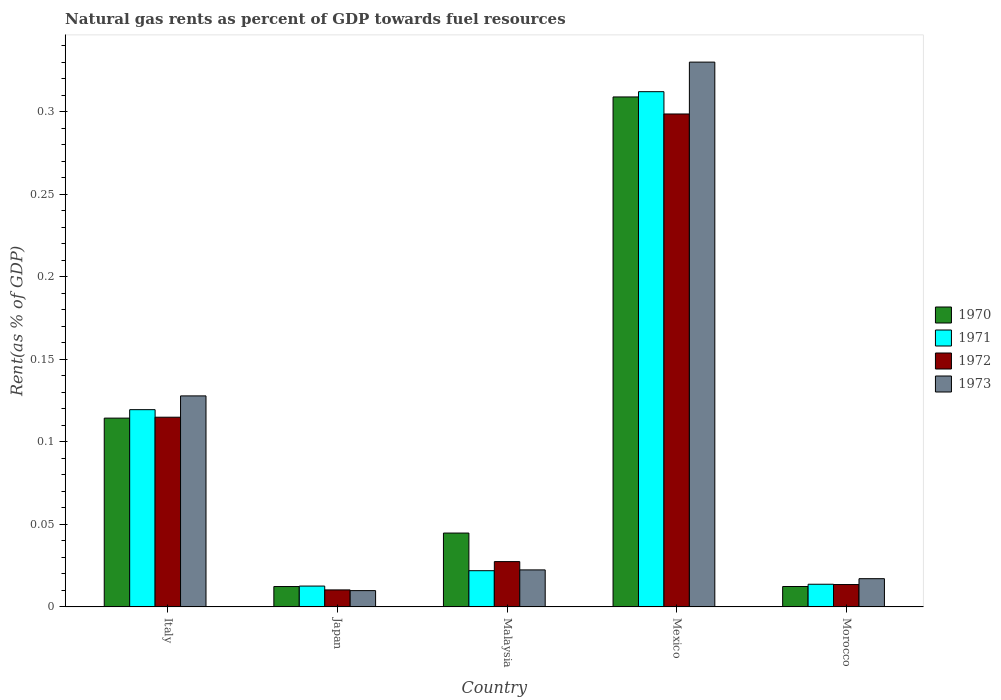How many different coloured bars are there?
Give a very brief answer. 4. How many groups of bars are there?
Give a very brief answer. 5. How many bars are there on the 1st tick from the left?
Offer a terse response. 4. How many bars are there on the 3rd tick from the right?
Give a very brief answer. 4. What is the matural gas rent in 1973 in Malaysia?
Keep it short and to the point. 0.02. Across all countries, what is the maximum matural gas rent in 1972?
Offer a very short reply. 0.3. Across all countries, what is the minimum matural gas rent in 1973?
Keep it short and to the point. 0.01. What is the total matural gas rent in 1972 in the graph?
Provide a succinct answer. 0.46. What is the difference between the matural gas rent in 1973 in Japan and that in Mexico?
Give a very brief answer. -0.32. What is the difference between the matural gas rent in 1970 in Morocco and the matural gas rent in 1971 in Italy?
Make the answer very short. -0.11. What is the average matural gas rent in 1970 per country?
Your answer should be compact. 0.1. What is the difference between the matural gas rent of/in 1973 and matural gas rent of/in 1971 in Morocco?
Offer a very short reply. 0. In how many countries, is the matural gas rent in 1970 greater than 0.1 %?
Give a very brief answer. 2. What is the ratio of the matural gas rent in 1972 in Japan to that in Malaysia?
Provide a succinct answer. 0.38. Is the matural gas rent in 1970 in Malaysia less than that in Mexico?
Offer a terse response. Yes. What is the difference between the highest and the second highest matural gas rent in 1972?
Offer a terse response. 0.18. What is the difference between the highest and the lowest matural gas rent in 1972?
Your answer should be compact. 0.29. Is it the case that in every country, the sum of the matural gas rent in 1971 and matural gas rent in 1973 is greater than the sum of matural gas rent in 1970 and matural gas rent in 1972?
Ensure brevity in your answer.  No. What does the 3rd bar from the right in Mexico represents?
Provide a succinct answer. 1971. Is it the case that in every country, the sum of the matural gas rent in 1970 and matural gas rent in 1973 is greater than the matural gas rent in 1971?
Make the answer very short. Yes. How many countries are there in the graph?
Offer a very short reply. 5. Are the values on the major ticks of Y-axis written in scientific E-notation?
Ensure brevity in your answer.  No. Does the graph contain grids?
Ensure brevity in your answer.  No. How many legend labels are there?
Make the answer very short. 4. How are the legend labels stacked?
Your answer should be very brief. Vertical. What is the title of the graph?
Your response must be concise. Natural gas rents as percent of GDP towards fuel resources. What is the label or title of the X-axis?
Provide a short and direct response. Country. What is the label or title of the Y-axis?
Keep it short and to the point. Rent(as % of GDP). What is the Rent(as % of GDP) of 1970 in Italy?
Offer a terse response. 0.11. What is the Rent(as % of GDP) of 1971 in Italy?
Provide a short and direct response. 0.12. What is the Rent(as % of GDP) in 1972 in Italy?
Offer a very short reply. 0.11. What is the Rent(as % of GDP) of 1973 in Italy?
Your answer should be compact. 0.13. What is the Rent(as % of GDP) of 1970 in Japan?
Your response must be concise. 0.01. What is the Rent(as % of GDP) of 1971 in Japan?
Your answer should be very brief. 0.01. What is the Rent(as % of GDP) of 1972 in Japan?
Provide a succinct answer. 0.01. What is the Rent(as % of GDP) in 1973 in Japan?
Provide a short and direct response. 0.01. What is the Rent(as % of GDP) in 1970 in Malaysia?
Provide a short and direct response. 0.04. What is the Rent(as % of GDP) in 1971 in Malaysia?
Provide a succinct answer. 0.02. What is the Rent(as % of GDP) in 1972 in Malaysia?
Provide a short and direct response. 0.03. What is the Rent(as % of GDP) in 1973 in Malaysia?
Provide a short and direct response. 0.02. What is the Rent(as % of GDP) of 1970 in Mexico?
Offer a terse response. 0.31. What is the Rent(as % of GDP) of 1971 in Mexico?
Provide a short and direct response. 0.31. What is the Rent(as % of GDP) in 1972 in Mexico?
Your response must be concise. 0.3. What is the Rent(as % of GDP) in 1973 in Mexico?
Your answer should be compact. 0.33. What is the Rent(as % of GDP) in 1970 in Morocco?
Your answer should be very brief. 0.01. What is the Rent(as % of GDP) in 1971 in Morocco?
Make the answer very short. 0.01. What is the Rent(as % of GDP) of 1972 in Morocco?
Your response must be concise. 0.01. What is the Rent(as % of GDP) of 1973 in Morocco?
Your response must be concise. 0.02. Across all countries, what is the maximum Rent(as % of GDP) of 1970?
Your response must be concise. 0.31. Across all countries, what is the maximum Rent(as % of GDP) in 1971?
Your answer should be very brief. 0.31. Across all countries, what is the maximum Rent(as % of GDP) in 1972?
Ensure brevity in your answer.  0.3. Across all countries, what is the maximum Rent(as % of GDP) of 1973?
Provide a short and direct response. 0.33. Across all countries, what is the minimum Rent(as % of GDP) of 1970?
Provide a succinct answer. 0.01. Across all countries, what is the minimum Rent(as % of GDP) of 1971?
Provide a succinct answer. 0.01. Across all countries, what is the minimum Rent(as % of GDP) of 1972?
Make the answer very short. 0.01. Across all countries, what is the minimum Rent(as % of GDP) in 1973?
Ensure brevity in your answer.  0.01. What is the total Rent(as % of GDP) in 1970 in the graph?
Offer a very short reply. 0.49. What is the total Rent(as % of GDP) in 1971 in the graph?
Provide a succinct answer. 0.48. What is the total Rent(as % of GDP) in 1972 in the graph?
Give a very brief answer. 0.46. What is the total Rent(as % of GDP) in 1973 in the graph?
Give a very brief answer. 0.51. What is the difference between the Rent(as % of GDP) of 1970 in Italy and that in Japan?
Your answer should be very brief. 0.1. What is the difference between the Rent(as % of GDP) in 1971 in Italy and that in Japan?
Make the answer very short. 0.11. What is the difference between the Rent(as % of GDP) in 1972 in Italy and that in Japan?
Provide a succinct answer. 0.1. What is the difference between the Rent(as % of GDP) of 1973 in Italy and that in Japan?
Your response must be concise. 0.12. What is the difference between the Rent(as % of GDP) of 1970 in Italy and that in Malaysia?
Your response must be concise. 0.07. What is the difference between the Rent(as % of GDP) of 1971 in Italy and that in Malaysia?
Give a very brief answer. 0.1. What is the difference between the Rent(as % of GDP) of 1972 in Italy and that in Malaysia?
Offer a very short reply. 0.09. What is the difference between the Rent(as % of GDP) in 1973 in Italy and that in Malaysia?
Your answer should be compact. 0.11. What is the difference between the Rent(as % of GDP) of 1970 in Italy and that in Mexico?
Give a very brief answer. -0.19. What is the difference between the Rent(as % of GDP) in 1971 in Italy and that in Mexico?
Keep it short and to the point. -0.19. What is the difference between the Rent(as % of GDP) of 1972 in Italy and that in Mexico?
Keep it short and to the point. -0.18. What is the difference between the Rent(as % of GDP) of 1973 in Italy and that in Mexico?
Your response must be concise. -0.2. What is the difference between the Rent(as % of GDP) in 1970 in Italy and that in Morocco?
Give a very brief answer. 0.1. What is the difference between the Rent(as % of GDP) in 1971 in Italy and that in Morocco?
Offer a very short reply. 0.11. What is the difference between the Rent(as % of GDP) of 1972 in Italy and that in Morocco?
Your answer should be very brief. 0.1. What is the difference between the Rent(as % of GDP) of 1973 in Italy and that in Morocco?
Offer a terse response. 0.11. What is the difference between the Rent(as % of GDP) of 1970 in Japan and that in Malaysia?
Offer a terse response. -0.03. What is the difference between the Rent(as % of GDP) of 1971 in Japan and that in Malaysia?
Offer a terse response. -0.01. What is the difference between the Rent(as % of GDP) in 1972 in Japan and that in Malaysia?
Provide a succinct answer. -0.02. What is the difference between the Rent(as % of GDP) in 1973 in Japan and that in Malaysia?
Provide a succinct answer. -0.01. What is the difference between the Rent(as % of GDP) in 1970 in Japan and that in Mexico?
Ensure brevity in your answer.  -0.3. What is the difference between the Rent(as % of GDP) in 1971 in Japan and that in Mexico?
Ensure brevity in your answer.  -0.3. What is the difference between the Rent(as % of GDP) of 1972 in Japan and that in Mexico?
Give a very brief answer. -0.29. What is the difference between the Rent(as % of GDP) in 1973 in Japan and that in Mexico?
Your response must be concise. -0.32. What is the difference between the Rent(as % of GDP) of 1971 in Japan and that in Morocco?
Make the answer very short. -0. What is the difference between the Rent(as % of GDP) of 1972 in Japan and that in Morocco?
Offer a very short reply. -0. What is the difference between the Rent(as % of GDP) in 1973 in Japan and that in Morocco?
Keep it short and to the point. -0.01. What is the difference between the Rent(as % of GDP) of 1970 in Malaysia and that in Mexico?
Your answer should be compact. -0.26. What is the difference between the Rent(as % of GDP) of 1971 in Malaysia and that in Mexico?
Offer a very short reply. -0.29. What is the difference between the Rent(as % of GDP) in 1972 in Malaysia and that in Mexico?
Provide a short and direct response. -0.27. What is the difference between the Rent(as % of GDP) in 1973 in Malaysia and that in Mexico?
Your answer should be very brief. -0.31. What is the difference between the Rent(as % of GDP) in 1970 in Malaysia and that in Morocco?
Ensure brevity in your answer.  0.03. What is the difference between the Rent(as % of GDP) of 1971 in Malaysia and that in Morocco?
Your answer should be compact. 0.01. What is the difference between the Rent(as % of GDP) in 1972 in Malaysia and that in Morocco?
Your response must be concise. 0.01. What is the difference between the Rent(as % of GDP) of 1973 in Malaysia and that in Morocco?
Ensure brevity in your answer.  0.01. What is the difference between the Rent(as % of GDP) of 1970 in Mexico and that in Morocco?
Offer a very short reply. 0.3. What is the difference between the Rent(as % of GDP) in 1971 in Mexico and that in Morocco?
Your response must be concise. 0.3. What is the difference between the Rent(as % of GDP) of 1972 in Mexico and that in Morocco?
Your answer should be very brief. 0.28. What is the difference between the Rent(as % of GDP) in 1973 in Mexico and that in Morocco?
Offer a very short reply. 0.31. What is the difference between the Rent(as % of GDP) of 1970 in Italy and the Rent(as % of GDP) of 1971 in Japan?
Offer a very short reply. 0.1. What is the difference between the Rent(as % of GDP) of 1970 in Italy and the Rent(as % of GDP) of 1972 in Japan?
Provide a short and direct response. 0.1. What is the difference between the Rent(as % of GDP) of 1970 in Italy and the Rent(as % of GDP) of 1973 in Japan?
Your response must be concise. 0.1. What is the difference between the Rent(as % of GDP) in 1971 in Italy and the Rent(as % of GDP) in 1972 in Japan?
Keep it short and to the point. 0.11. What is the difference between the Rent(as % of GDP) of 1971 in Italy and the Rent(as % of GDP) of 1973 in Japan?
Provide a short and direct response. 0.11. What is the difference between the Rent(as % of GDP) of 1972 in Italy and the Rent(as % of GDP) of 1973 in Japan?
Keep it short and to the point. 0.1. What is the difference between the Rent(as % of GDP) in 1970 in Italy and the Rent(as % of GDP) in 1971 in Malaysia?
Offer a very short reply. 0.09. What is the difference between the Rent(as % of GDP) of 1970 in Italy and the Rent(as % of GDP) of 1972 in Malaysia?
Your response must be concise. 0.09. What is the difference between the Rent(as % of GDP) of 1970 in Italy and the Rent(as % of GDP) of 1973 in Malaysia?
Make the answer very short. 0.09. What is the difference between the Rent(as % of GDP) in 1971 in Italy and the Rent(as % of GDP) in 1972 in Malaysia?
Ensure brevity in your answer.  0.09. What is the difference between the Rent(as % of GDP) in 1971 in Italy and the Rent(as % of GDP) in 1973 in Malaysia?
Make the answer very short. 0.1. What is the difference between the Rent(as % of GDP) of 1972 in Italy and the Rent(as % of GDP) of 1973 in Malaysia?
Provide a short and direct response. 0.09. What is the difference between the Rent(as % of GDP) in 1970 in Italy and the Rent(as % of GDP) in 1971 in Mexico?
Keep it short and to the point. -0.2. What is the difference between the Rent(as % of GDP) in 1970 in Italy and the Rent(as % of GDP) in 1972 in Mexico?
Offer a very short reply. -0.18. What is the difference between the Rent(as % of GDP) in 1970 in Italy and the Rent(as % of GDP) in 1973 in Mexico?
Keep it short and to the point. -0.22. What is the difference between the Rent(as % of GDP) of 1971 in Italy and the Rent(as % of GDP) of 1972 in Mexico?
Keep it short and to the point. -0.18. What is the difference between the Rent(as % of GDP) of 1971 in Italy and the Rent(as % of GDP) of 1973 in Mexico?
Provide a short and direct response. -0.21. What is the difference between the Rent(as % of GDP) in 1972 in Italy and the Rent(as % of GDP) in 1973 in Mexico?
Ensure brevity in your answer.  -0.22. What is the difference between the Rent(as % of GDP) in 1970 in Italy and the Rent(as % of GDP) in 1971 in Morocco?
Make the answer very short. 0.1. What is the difference between the Rent(as % of GDP) in 1970 in Italy and the Rent(as % of GDP) in 1972 in Morocco?
Provide a succinct answer. 0.1. What is the difference between the Rent(as % of GDP) of 1970 in Italy and the Rent(as % of GDP) of 1973 in Morocco?
Make the answer very short. 0.1. What is the difference between the Rent(as % of GDP) of 1971 in Italy and the Rent(as % of GDP) of 1972 in Morocco?
Provide a short and direct response. 0.11. What is the difference between the Rent(as % of GDP) in 1971 in Italy and the Rent(as % of GDP) in 1973 in Morocco?
Offer a terse response. 0.1. What is the difference between the Rent(as % of GDP) in 1972 in Italy and the Rent(as % of GDP) in 1973 in Morocco?
Your answer should be compact. 0.1. What is the difference between the Rent(as % of GDP) in 1970 in Japan and the Rent(as % of GDP) in 1971 in Malaysia?
Provide a short and direct response. -0.01. What is the difference between the Rent(as % of GDP) of 1970 in Japan and the Rent(as % of GDP) of 1972 in Malaysia?
Give a very brief answer. -0.02. What is the difference between the Rent(as % of GDP) in 1970 in Japan and the Rent(as % of GDP) in 1973 in Malaysia?
Give a very brief answer. -0.01. What is the difference between the Rent(as % of GDP) in 1971 in Japan and the Rent(as % of GDP) in 1972 in Malaysia?
Give a very brief answer. -0.01. What is the difference between the Rent(as % of GDP) in 1971 in Japan and the Rent(as % of GDP) in 1973 in Malaysia?
Ensure brevity in your answer.  -0.01. What is the difference between the Rent(as % of GDP) of 1972 in Japan and the Rent(as % of GDP) of 1973 in Malaysia?
Keep it short and to the point. -0.01. What is the difference between the Rent(as % of GDP) of 1970 in Japan and the Rent(as % of GDP) of 1971 in Mexico?
Provide a succinct answer. -0.3. What is the difference between the Rent(as % of GDP) of 1970 in Japan and the Rent(as % of GDP) of 1972 in Mexico?
Your answer should be very brief. -0.29. What is the difference between the Rent(as % of GDP) in 1970 in Japan and the Rent(as % of GDP) in 1973 in Mexico?
Keep it short and to the point. -0.32. What is the difference between the Rent(as % of GDP) of 1971 in Japan and the Rent(as % of GDP) of 1972 in Mexico?
Make the answer very short. -0.29. What is the difference between the Rent(as % of GDP) in 1971 in Japan and the Rent(as % of GDP) in 1973 in Mexico?
Offer a very short reply. -0.32. What is the difference between the Rent(as % of GDP) in 1972 in Japan and the Rent(as % of GDP) in 1973 in Mexico?
Your response must be concise. -0.32. What is the difference between the Rent(as % of GDP) of 1970 in Japan and the Rent(as % of GDP) of 1971 in Morocco?
Your answer should be very brief. -0. What is the difference between the Rent(as % of GDP) of 1970 in Japan and the Rent(as % of GDP) of 1972 in Morocco?
Provide a short and direct response. -0. What is the difference between the Rent(as % of GDP) in 1970 in Japan and the Rent(as % of GDP) in 1973 in Morocco?
Offer a terse response. -0. What is the difference between the Rent(as % of GDP) of 1971 in Japan and the Rent(as % of GDP) of 1972 in Morocco?
Your answer should be very brief. -0. What is the difference between the Rent(as % of GDP) of 1971 in Japan and the Rent(as % of GDP) of 1973 in Morocco?
Keep it short and to the point. -0. What is the difference between the Rent(as % of GDP) of 1972 in Japan and the Rent(as % of GDP) of 1973 in Morocco?
Offer a terse response. -0.01. What is the difference between the Rent(as % of GDP) of 1970 in Malaysia and the Rent(as % of GDP) of 1971 in Mexico?
Provide a succinct answer. -0.27. What is the difference between the Rent(as % of GDP) in 1970 in Malaysia and the Rent(as % of GDP) in 1972 in Mexico?
Your response must be concise. -0.25. What is the difference between the Rent(as % of GDP) of 1970 in Malaysia and the Rent(as % of GDP) of 1973 in Mexico?
Your answer should be compact. -0.29. What is the difference between the Rent(as % of GDP) in 1971 in Malaysia and the Rent(as % of GDP) in 1972 in Mexico?
Ensure brevity in your answer.  -0.28. What is the difference between the Rent(as % of GDP) in 1971 in Malaysia and the Rent(as % of GDP) in 1973 in Mexico?
Your answer should be compact. -0.31. What is the difference between the Rent(as % of GDP) of 1972 in Malaysia and the Rent(as % of GDP) of 1973 in Mexico?
Provide a short and direct response. -0.3. What is the difference between the Rent(as % of GDP) of 1970 in Malaysia and the Rent(as % of GDP) of 1971 in Morocco?
Your response must be concise. 0.03. What is the difference between the Rent(as % of GDP) in 1970 in Malaysia and the Rent(as % of GDP) in 1972 in Morocco?
Provide a short and direct response. 0.03. What is the difference between the Rent(as % of GDP) in 1970 in Malaysia and the Rent(as % of GDP) in 1973 in Morocco?
Your answer should be very brief. 0.03. What is the difference between the Rent(as % of GDP) in 1971 in Malaysia and the Rent(as % of GDP) in 1972 in Morocco?
Provide a succinct answer. 0.01. What is the difference between the Rent(as % of GDP) in 1971 in Malaysia and the Rent(as % of GDP) in 1973 in Morocco?
Give a very brief answer. 0. What is the difference between the Rent(as % of GDP) in 1972 in Malaysia and the Rent(as % of GDP) in 1973 in Morocco?
Ensure brevity in your answer.  0.01. What is the difference between the Rent(as % of GDP) in 1970 in Mexico and the Rent(as % of GDP) in 1971 in Morocco?
Offer a terse response. 0.3. What is the difference between the Rent(as % of GDP) in 1970 in Mexico and the Rent(as % of GDP) in 1972 in Morocco?
Make the answer very short. 0.3. What is the difference between the Rent(as % of GDP) in 1970 in Mexico and the Rent(as % of GDP) in 1973 in Morocco?
Provide a short and direct response. 0.29. What is the difference between the Rent(as % of GDP) in 1971 in Mexico and the Rent(as % of GDP) in 1972 in Morocco?
Offer a terse response. 0.3. What is the difference between the Rent(as % of GDP) in 1971 in Mexico and the Rent(as % of GDP) in 1973 in Morocco?
Make the answer very short. 0.29. What is the difference between the Rent(as % of GDP) in 1972 in Mexico and the Rent(as % of GDP) in 1973 in Morocco?
Your answer should be compact. 0.28. What is the average Rent(as % of GDP) in 1970 per country?
Keep it short and to the point. 0.1. What is the average Rent(as % of GDP) of 1971 per country?
Your response must be concise. 0.1. What is the average Rent(as % of GDP) in 1972 per country?
Your answer should be compact. 0.09. What is the average Rent(as % of GDP) in 1973 per country?
Keep it short and to the point. 0.1. What is the difference between the Rent(as % of GDP) in 1970 and Rent(as % of GDP) in 1971 in Italy?
Give a very brief answer. -0.01. What is the difference between the Rent(as % of GDP) of 1970 and Rent(as % of GDP) of 1972 in Italy?
Your answer should be very brief. -0. What is the difference between the Rent(as % of GDP) in 1970 and Rent(as % of GDP) in 1973 in Italy?
Give a very brief answer. -0.01. What is the difference between the Rent(as % of GDP) in 1971 and Rent(as % of GDP) in 1972 in Italy?
Provide a succinct answer. 0. What is the difference between the Rent(as % of GDP) of 1971 and Rent(as % of GDP) of 1973 in Italy?
Ensure brevity in your answer.  -0.01. What is the difference between the Rent(as % of GDP) of 1972 and Rent(as % of GDP) of 1973 in Italy?
Keep it short and to the point. -0.01. What is the difference between the Rent(as % of GDP) of 1970 and Rent(as % of GDP) of 1971 in Japan?
Provide a short and direct response. -0. What is the difference between the Rent(as % of GDP) of 1970 and Rent(as % of GDP) of 1972 in Japan?
Keep it short and to the point. 0. What is the difference between the Rent(as % of GDP) of 1970 and Rent(as % of GDP) of 1973 in Japan?
Your answer should be very brief. 0. What is the difference between the Rent(as % of GDP) in 1971 and Rent(as % of GDP) in 1972 in Japan?
Make the answer very short. 0. What is the difference between the Rent(as % of GDP) in 1971 and Rent(as % of GDP) in 1973 in Japan?
Provide a succinct answer. 0. What is the difference between the Rent(as % of GDP) of 1970 and Rent(as % of GDP) of 1971 in Malaysia?
Your answer should be compact. 0.02. What is the difference between the Rent(as % of GDP) of 1970 and Rent(as % of GDP) of 1972 in Malaysia?
Give a very brief answer. 0.02. What is the difference between the Rent(as % of GDP) in 1970 and Rent(as % of GDP) in 1973 in Malaysia?
Give a very brief answer. 0.02. What is the difference between the Rent(as % of GDP) in 1971 and Rent(as % of GDP) in 1972 in Malaysia?
Offer a terse response. -0.01. What is the difference between the Rent(as % of GDP) in 1971 and Rent(as % of GDP) in 1973 in Malaysia?
Offer a very short reply. -0. What is the difference between the Rent(as % of GDP) in 1972 and Rent(as % of GDP) in 1973 in Malaysia?
Your answer should be compact. 0.01. What is the difference between the Rent(as % of GDP) in 1970 and Rent(as % of GDP) in 1971 in Mexico?
Provide a succinct answer. -0. What is the difference between the Rent(as % of GDP) in 1970 and Rent(as % of GDP) in 1972 in Mexico?
Your answer should be very brief. 0.01. What is the difference between the Rent(as % of GDP) of 1970 and Rent(as % of GDP) of 1973 in Mexico?
Offer a very short reply. -0.02. What is the difference between the Rent(as % of GDP) of 1971 and Rent(as % of GDP) of 1972 in Mexico?
Provide a short and direct response. 0.01. What is the difference between the Rent(as % of GDP) in 1971 and Rent(as % of GDP) in 1973 in Mexico?
Provide a succinct answer. -0.02. What is the difference between the Rent(as % of GDP) of 1972 and Rent(as % of GDP) of 1973 in Mexico?
Provide a short and direct response. -0.03. What is the difference between the Rent(as % of GDP) of 1970 and Rent(as % of GDP) of 1971 in Morocco?
Ensure brevity in your answer.  -0. What is the difference between the Rent(as % of GDP) in 1970 and Rent(as % of GDP) in 1972 in Morocco?
Your response must be concise. -0. What is the difference between the Rent(as % of GDP) in 1970 and Rent(as % of GDP) in 1973 in Morocco?
Keep it short and to the point. -0. What is the difference between the Rent(as % of GDP) of 1971 and Rent(as % of GDP) of 1972 in Morocco?
Provide a succinct answer. 0. What is the difference between the Rent(as % of GDP) of 1971 and Rent(as % of GDP) of 1973 in Morocco?
Ensure brevity in your answer.  -0. What is the difference between the Rent(as % of GDP) in 1972 and Rent(as % of GDP) in 1973 in Morocco?
Offer a terse response. -0. What is the ratio of the Rent(as % of GDP) of 1970 in Italy to that in Japan?
Your answer should be very brief. 9.27. What is the ratio of the Rent(as % of GDP) of 1971 in Italy to that in Japan?
Make the answer very short. 9.46. What is the ratio of the Rent(as % of GDP) of 1972 in Italy to that in Japan?
Your answer should be compact. 11.16. What is the ratio of the Rent(as % of GDP) in 1973 in Italy to that in Japan?
Provide a succinct answer. 12.96. What is the ratio of the Rent(as % of GDP) of 1970 in Italy to that in Malaysia?
Give a very brief answer. 2.56. What is the ratio of the Rent(as % of GDP) in 1971 in Italy to that in Malaysia?
Keep it short and to the point. 5.45. What is the ratio of the Rent(as % of GDP) in 1972 in Italy to that in Malaysia?
Offer a terse response. 4.19. What is the ratio of the Rent(as % of GDP) of 1973 in Italy to that in Malaysia?
Provide a succinct answer. 5.7. What is the ratio of the Rent(as % of GDP) in 1970 in Italy to that in Mexico?
Make the answer very short. 0.37. What is the ratio of the Rent(as % of GDP) in 1971 in Italy to that in Mexico?
Offer a terse response. 0.38. What is the ratio of the Rent(as % of GDP) of 1972 in Italy to that in Mexico?
Your answer should be very brief. 0.38. What is the ratio of the Rent(as % of GDP) of 1973 in Italy to that in Mexico?
Your response must be concise. 0.39. What is the ratio of the Rent(as % of GDP) in 1970 in Italy to that in Morocco?
Your answer should be very brief. 9.25. What is the ratio of the Rent(as % of GDP) of 1971 in Italy to that in Morocco?
Your answer should be very brief. 8.7. What is the ratio of the Rent(as % of GDP) in 1972 in Italy to that in Morocco?
Your answer should be compact. 8.48. What is the ratio of the Rent(as % of GDP) of 1973 in Italy to that in Morocco?
Make the answer very short. 7.47. What is the ratio of the Rent(as % of GDP) in 1970 in Japan to that in Malaysia?
Your answer should be compact. 0.28. What is the ratio of the Rent(as % of GDP) in 1971 in Japan to that in Malaysia?
Keep it short and to the point. 0.58. What is the ratio of the Rent(as % of GDP) in 1972 in Japan to that in Malaysia?
Your response must be concise. 0.38. What is the ratio of the Rent(as % of GDP) of 1973 in Japan to that in Malaysia?
Your response must be concise. 0.44. What is the ratio of the Rent(as % of GDP) in 1970 in Japan to that in Mexico?
Give a very brief answer. 0.04. What is the ratio of the Rent(as % of GDP) in 1971 in Japan to that in Mexico?
Make the answer very short. 0.04. What is the ratio of the Rent(as % of GDP) in 1972 in Japan to that in Mexico?
Keep it short and to the point. 0.03. What is the ratio of the Rent(as % of GDP) of 1973 in Japan to that in Mexico?
Keep it short and to the point. 0.03. What is the ratio of the Rent(as % of GDP) of 1970 in Japan to that in Morocco?
Your response must be concise. 1. What is the ratio of the Rent(as % of GDP) of 1972 in Japan to that in Morocco?
Offer a very short reply. 0.76. What is the ratio of the Rent(as % of GDP) in 1973 in Japan to that in Morocco?
Offer a terse response. 0.58. What is the ratio of the Rent(as % of GDP) of 1970 in Malaysia to that in Mexico?
Your answer should be very brief. 0.14. What is the ratio of the Rent(as % of GDP) in 1971 in Malaysia to that in Mexico?
Make the answer very short. 0.07. What is the ratio of the Rent(as % of GDP) of 1972 in Malaysia to that in Mexico?
Offer a very short reply. 0.09. What is the ratio of the Rent(as % of GDP) in 1973 in Malaysia to that in Mexico?
Your answer should be very brief. 0.07. What is the ratio of the Rent(as % of GDP) in 1970 in Malaysia to that in Morocco?
Offer a terse response. 3.62. What is the ratio of the Rent(as % of GDP) in 1971 in Malaysia to that in Morocco?
Your answer should be compact. 1.6. What is the ratio of the Rent(as % of GDP) of 1972 in Malaysia to that in Morocco?
Provide a succinct answer. 2.03. What is the ratio of the Rent(as % of GDP) in 1973 in Malaysia to that in Morocco?
Your response must be concise. 1.31. What is the ratio of the Rent(as % of GDP) of 1970 in Mexico to that in Morocco?
Offer a very short reply. 25. What is the ratio of the Rent(as % of GDP) in 1971 in Mexico to that in Morocco?
Give a very brief answer. 22.74. What is the ratio of the Rent(as % of GDP) in 1972 in Mexico to that in Morocco?
Offer a very short reply. 22.04. What is the ratio of the Rent(as % of GDP) in 1973 in Mexico to that in Morocco?
Make the answer very short. 19.3. What is the difference between the highest and the second highest Rent(as % of GDP) in 1970?
Keep it short and to the point. 0.19. What is the difference between the highest and the second highest Rent(as % of GDP) in 1971?
Give a very brief answer. 0.19. What is the difference between the highest and the second highest Rent(as % of GDP) in 1972?
Your answer should be very brief. 0.18. What is the difference between the highest and the second highest Rent(as % of GDP) of 1973?
Ensure brevity in your answer.  0.2. What is the difference between the highest and the lowest Rent(as % of GDP) in 1970?
Provide a short and direct response. 0.3. What is the difference between the highest and the lowest Rent(as % of GDP) in 1971?
Make the answer very short. 0.3. What is the difference between the highest and the lowest Rent(as % of GDP) in 1972?
Your response must be concise. 0.29. What is the difference between the highest and the lowest Rent(as % of GDP) of 1973?
Offer a terse response. 0.32. 